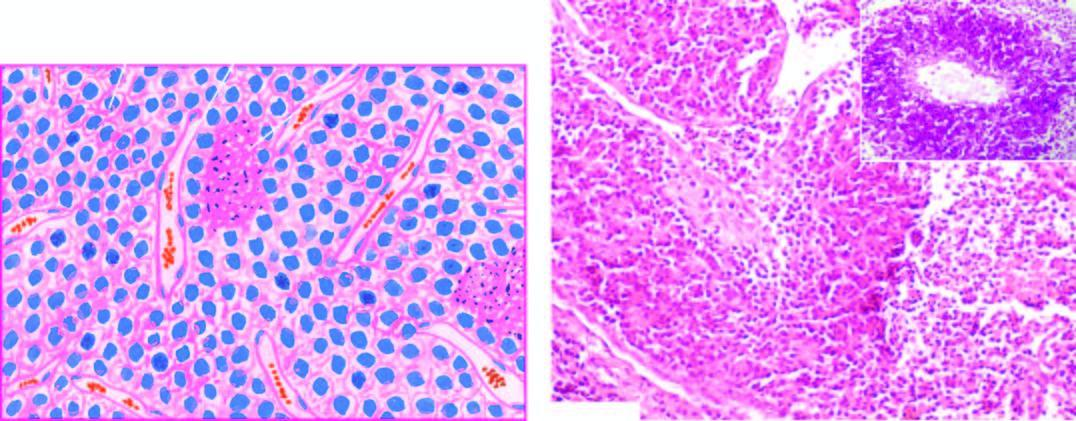re the lipofuscin pigment granules also included?
Answer the question using a single word or phrase. No 